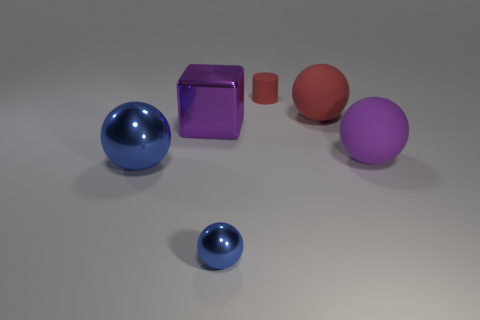Subtract all red rubber balls. How many balls are left? 3 Add 1 tiny brown objects. How many objects exist? 7 Subtract all brown blocks. How many blue spheres are left? 2 Subtract all red balls. How many balls are left? 3 Subtract all small green shiny blocks. Subtract all small blue metal objects. How many objects are left? 5 Add 3 red objects. How many red objects are left? 5 Add 1 big gray rubber cubes. How many big gray rubber cubes exist? 1 Subtract 1 purple blocks. How many objects are left? 5 Subtract all blocks. How many objects are left? 5 Subtract all brown cubes. Subtract all brown cylinders. How many cubes are left? 1 